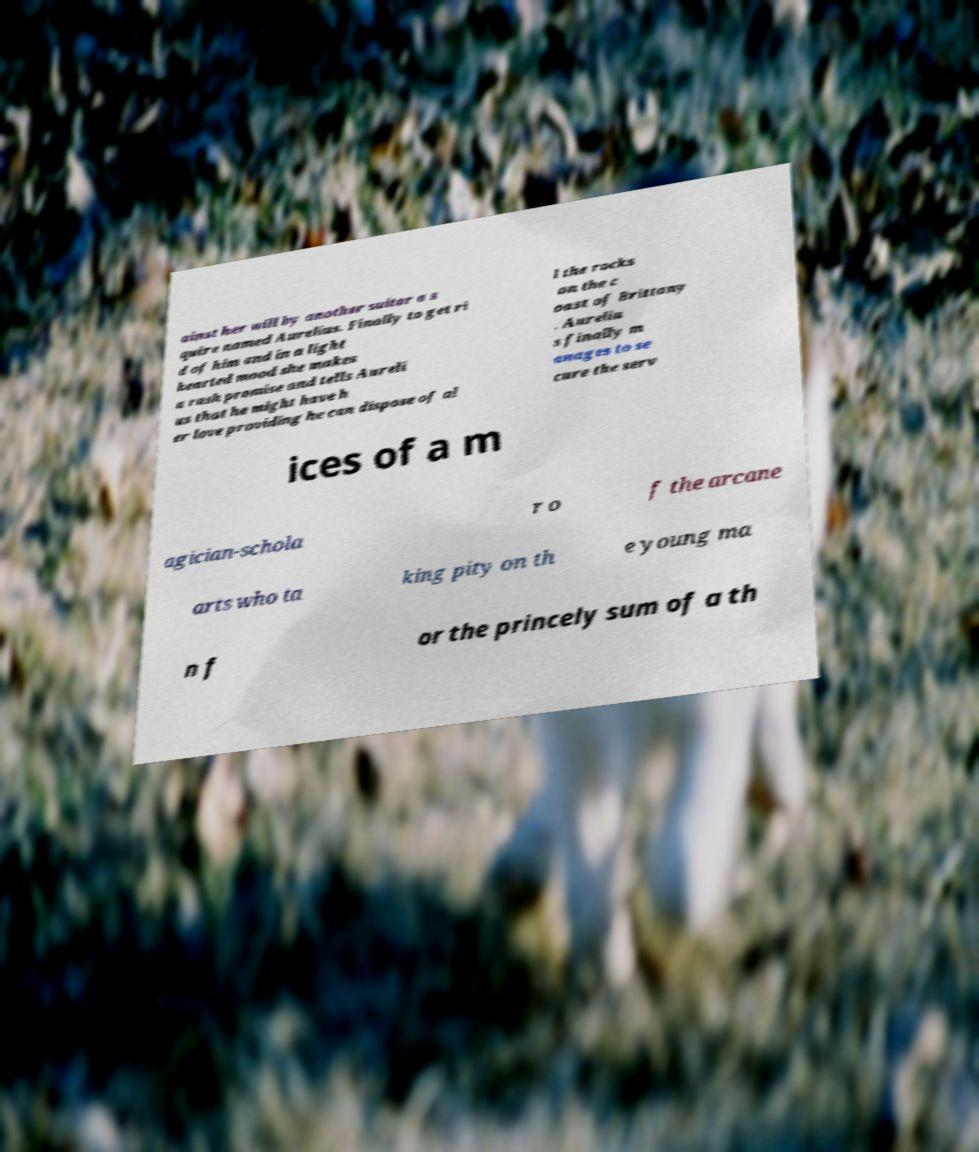Please identify and transcribe the text found in this image. ainst her will by another suitor a s quire named Aurelius. Finally to get ri d of him and in a light hearted mood she makes a rash promise and tells Aureli us that he might have h er love providing he can dispose of al l the rocks on the c oast of Brittany . Aureliu s finally m anages to se cure the serv ices of a m agician-schola r o f the arcane arts who ta king pity on th e young ma n f or the princely sum of a th 